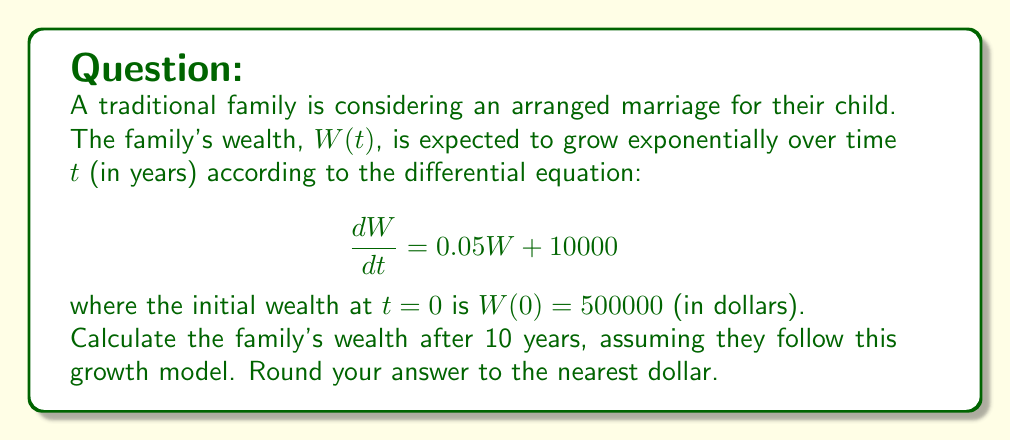Solve this math problem. To solve this first-order linear differential equation, we follow these steps:

1) The general form of the equation is: $\frac{dW}{dt} - 0.05W = 10000$

2) The integrating factor is: $e^{-\int 0.05 dt} = e^{-0.05t}$

3) Multiply both sides by the integrating factor:
   $e^{-0.05t}\frac{dW}{dt} - 0.05e^{-0.05t}W = 10000e^{-0.05t}$

4) The left side is now the derivative of $e^{-0.05t}W$:
   $\frac{d}{dt}(e^{-0.05t}W) = 10000e^{-0.05t}$

5) Integrate both sides:
   $e^{-0.05t}W = -200000e^{-0.05t} + C$

6) Solve for W:
   $W = -200000 + Ce^{0.05t}$

7) Use the initial condition $W(0) = 500000$ to find C:
   $500000 = -200000 + C$
   $C = 700000$

8) The particular solution is:
   $W(t) = -200000 + 700000e^{0.05t}$

9) Calculate W(10):
   $W(10) = -200000 + 700000e^{0.5}$
   $W(10) = -200000 + 700000 * 1.6487212707$
   $W(10) = 954105.28949$

10) Rounding to the nearest dollar:
    $W(10) ≈ 954105$
Answer: $954105 